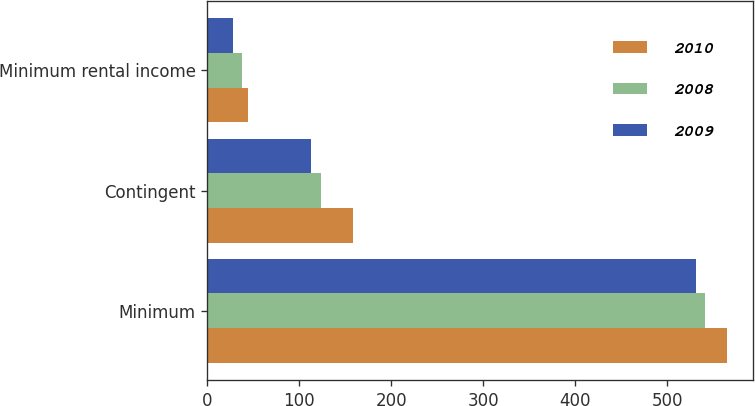Convert chart. <chart><loc_0><loc_0><loc_500><loc_500><stacked_bar_chart><ecel><fcel>Minimum<fcel>Contingent<fcel>Minimum rental income<nl><fcel>2010<fcel>565<fcel>158<fcel>44<nl><fcel>2008<fcel>541<fcel>123<fcel>38<nl><fcel>2009<fcel>531<fcel>113<fcel>28<nl></chart> 